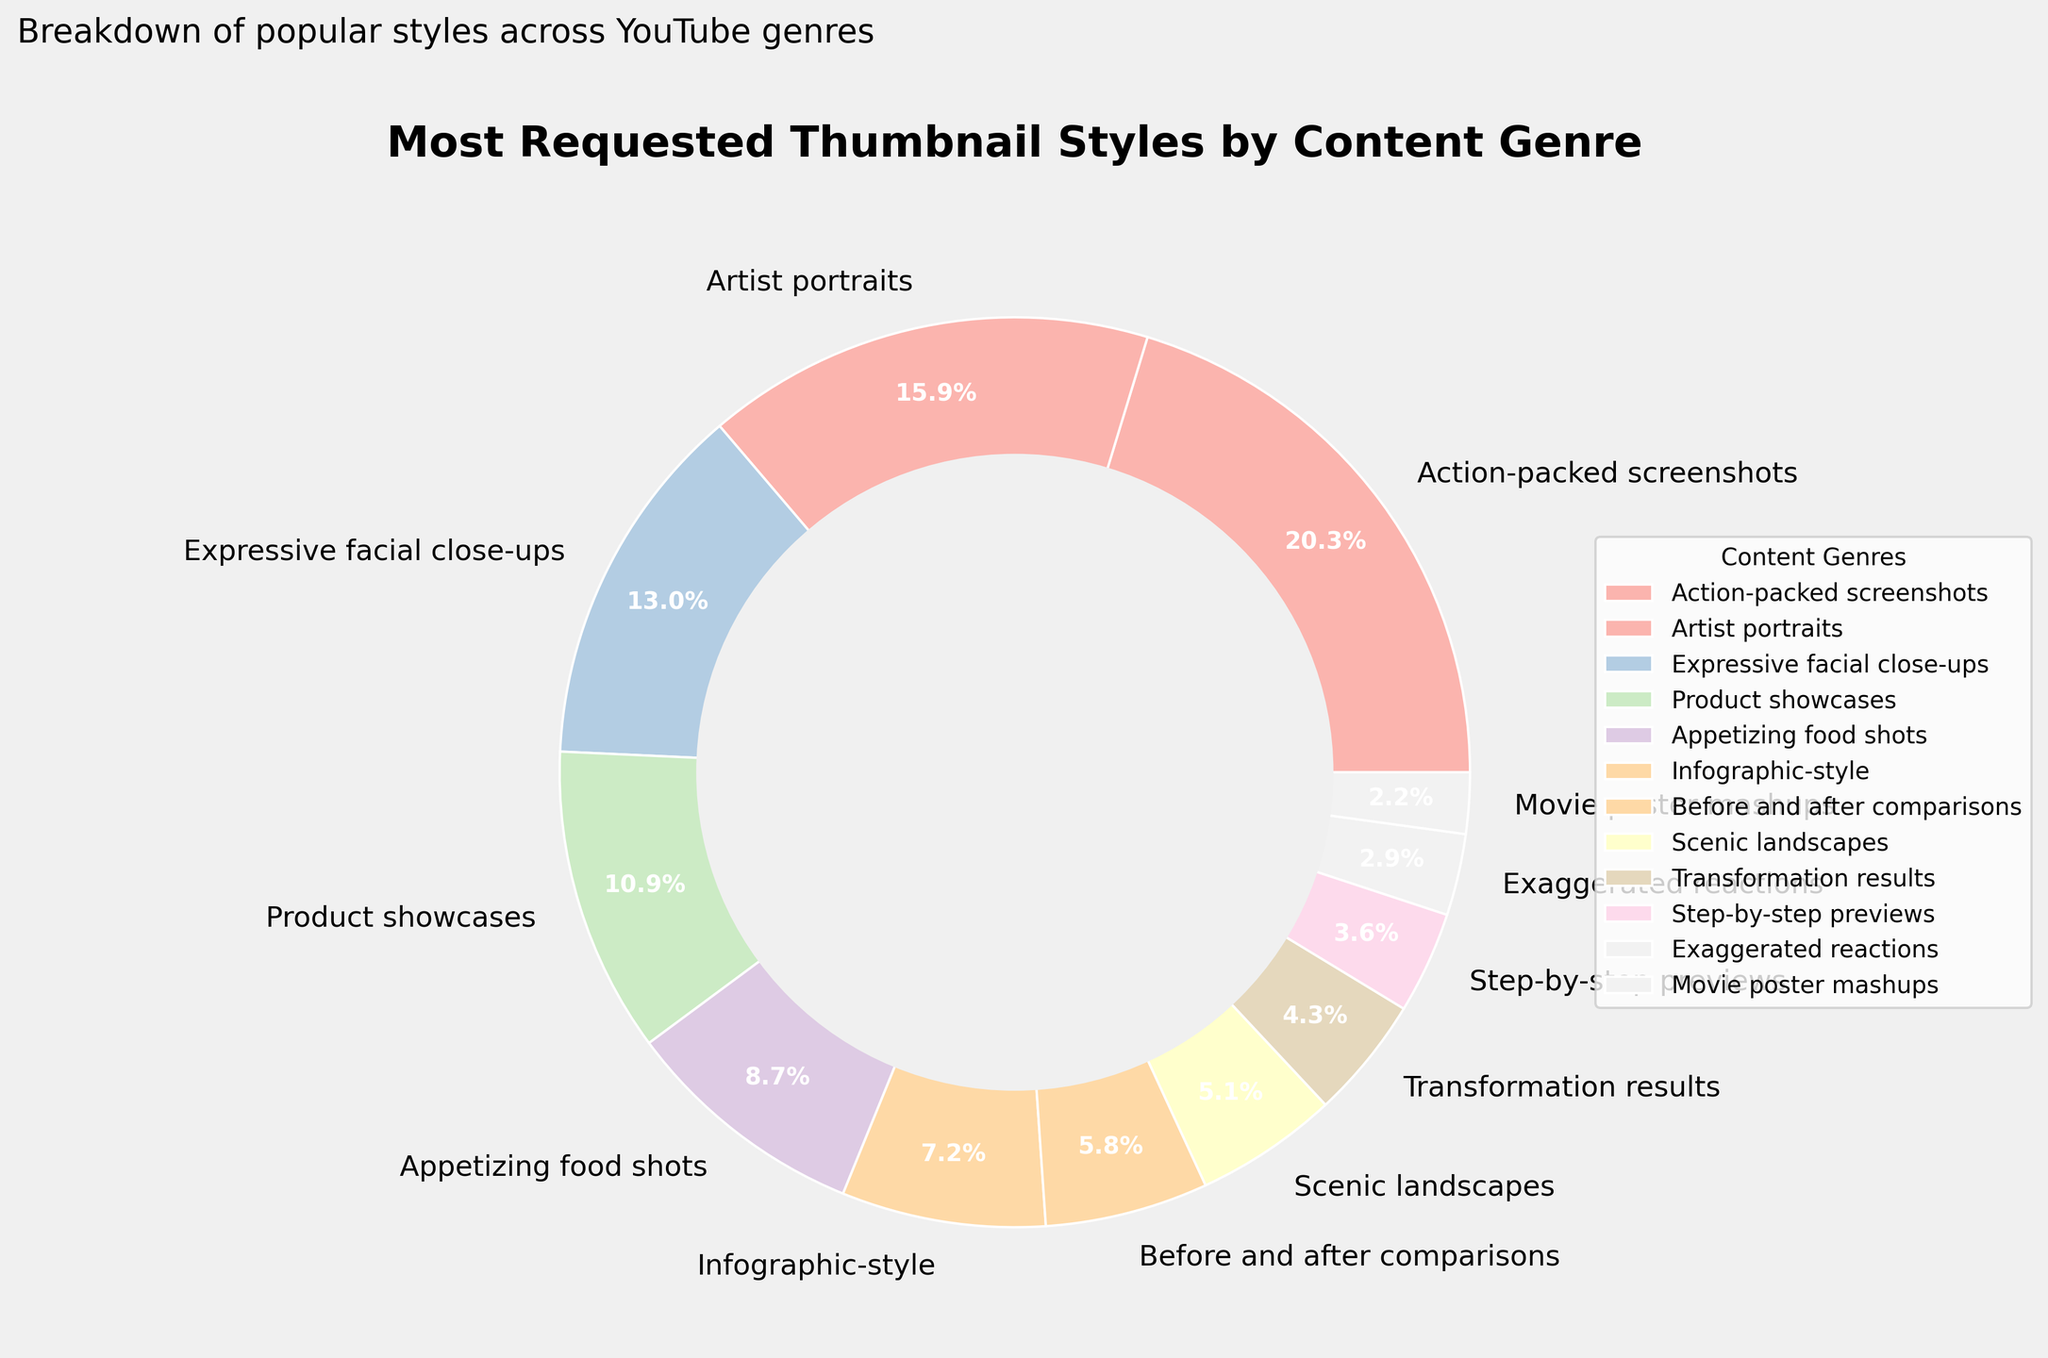What is the most requested thumbnail style for the Gaming genre? The pie chart clearly shows that "Action-packed screenshots" is the labeled style for the Gaming genre, and its segment occupies the largest section.
Answer: Action-packed screenshots What percentage of thumbnail styles are dedicated to the Music and Vlogs genres combined? According to the chart, Music genre uses 22% for "Artist portraits" and Vlogs use 18% for "Expressive facial close-ups." Adding these together: 22% + 18% = 40%.
Answer: 40% Which genre has a higher percentage of thumbnail styles, Travel or Fitness? The chart shows that Travel genre is represented by "Scenic landscapes" with 7%, while the Fitness genre is shown by "Transformation results" with 6%. Comparing these values, 7% > 6%.
Answer: Travel What is the difference in percentage between the highest and the lowest requested thumbnail styles? The highest requested style is for Gaming with 28% and the lowest is for Movie Reviews with 3%. The difference is 28% - 3% = 25%.
Answer: 25% What is the cumulative percentage of the three least requested thumbnail styles? The three least requested styles are Movie Reviews (3%), Comedy (4%), and DIY (5%). Summing these percentages: 3% + 4% + 5% = 12%.
Answer: 12% If we group Cooking, Education, and Beauty genres, what total percentage do they form? Cookings takes 12%, Education takes 10%, and Beauty takes 8%. Summing these together: 12% + 10% + 8% = 30%.
Answer: 30% Is the percentage of Product showcases thumbnails for Tech Reviews greater than the sum of Comedy and DIY genres? Tech Reviews have a percentage of 15%, while Comedy has 4% and DIY has 5%. Adding Comedy and DIY: 4% + 5% = 9%. Comparing these values, 15% > 9%.
Answer: Yes Which genre occupies the largest color wedge in the pie chart, and what is its percentage? The largest color wedge is for Gaming, and its percentage is 28%.
Answer: Gaming, 28% How many thumbnail styles have a percentage of 10% or more? Thumbnail styles equal to or exceeding 10% are: Gaming (28%), Music (22%), Vlogs (18%), Tech Reviews (15%), and Cooking (12%). Counting these gives 5.
Answer: 5 What percentage of thumbnail styles for educational content is infographics? The pie chart indicates that Infographic-style is 10%, which is dedicated to the Education genre.
Answer: 10% 